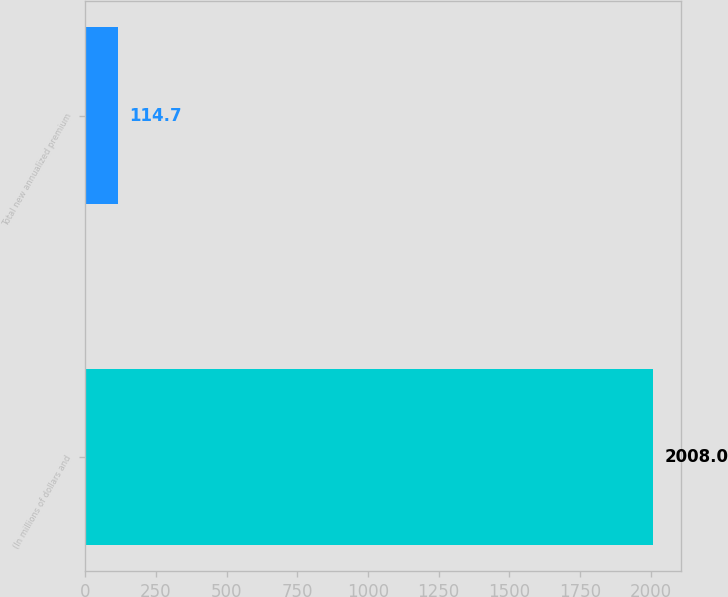<chart> <loc_0><loc_0><loc_500><loc_500><bar_chart><fcel>(In millions of dollars and<fcel>Total new annualized premium<nl><fcel>2008<fcel>114.7<nl></chart> 